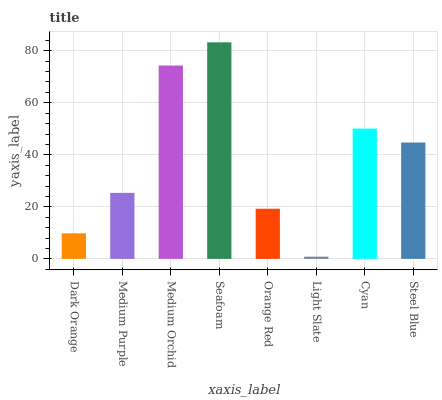Is Light Slate the minimum?
Answer yes or no. Yes. Is Seafoam the maximum?
Answer yes or no. Yes. Is Medium Purple the minimum?
Answer yes or no. No. Is Medium Purple the maximum?
Answer yes or no. No. Is Medium Purple greater than Dark Orange?
Answer yes or no. Yes. Is Dark Orange less than Medium Purple?
Answer yes or no. Yes. Is Dark Orange greater than Medium Purple?
Answer yes or no. No. Is Medium Purple less than Dark Orange?
Answer yes or no. No. Is Steel Blue the high median?
Answer yes or no. Yes. Is Medium Purple the low median?
Answer yes or no. Yes. Is Seafoam the high median?
Answer yes or no. No. Is Cyan the low median?
Answer yes or no. No. 